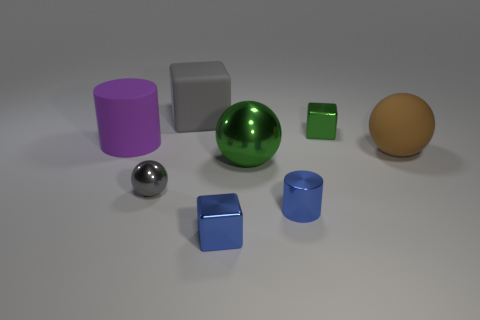Which objects appear to be reflective, and can you guess the material they might be made of? From the image, the large silver sphere and the small gray cube exhibit a high level of reflectivity, indicative of a metallic composition. The realistic reflections and shiny surfaces suggest they could be made of polished steel or a similar metal. How can you tell they're metallic just by looking? Metallic objects tend to reflect their surroundings more clearly and have a distinct shine compared to other materials. The way these objects mirror the environment and the highlights on their surfaces are typical characteristics of metals. 